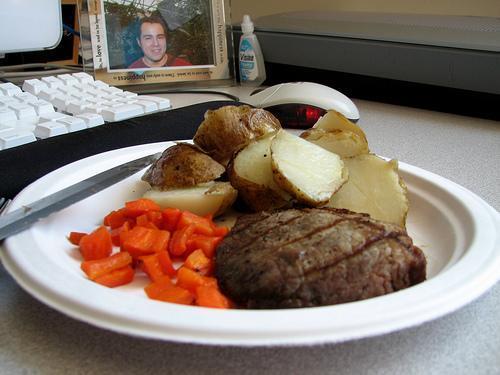How many potatoes are there?
Give a very brief answer. 7. 